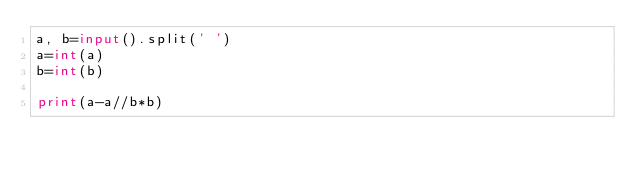Convert code to text. <code><loc_0><loc_0><loc_500><loc_500><_Python_>a, b=input().split(' ')
a=int(a)
b=int(b)

print(a-a//b*b)
</code> 